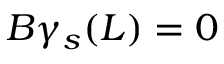<formula> <loc_0><loc_0><loc_500><loc_500>B \gamma _ { s } ( L ) = 0</formula> 